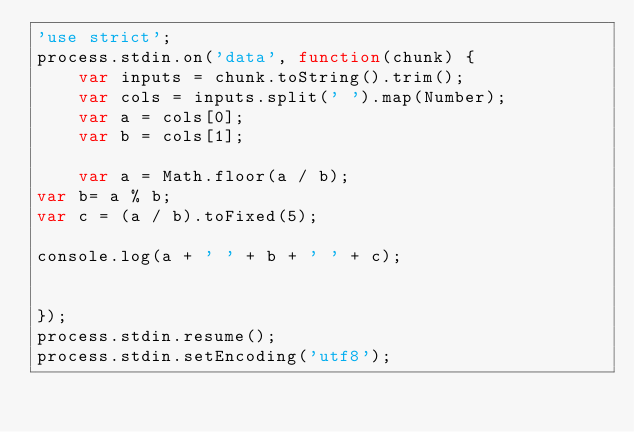<code> <loc_0><loc_0><loc_500><loc_500><_JavaScript_>'use strict';
process.stdin.on('data', function(chunk) {
    var inputs = chunk.toString().trim();
    var cols = inputs.split(' ').map(Number);
    var a = cols[0];
    var b = cols[1];

    var a = Math.floor(a / b);
var b= a % b;
var c = (a / b).toFixed(5);

console.log(a + ' ' + b + ' ' + c);


});
process.stdin.resume();
process.stdin.setEncoding('utf8');</code> 